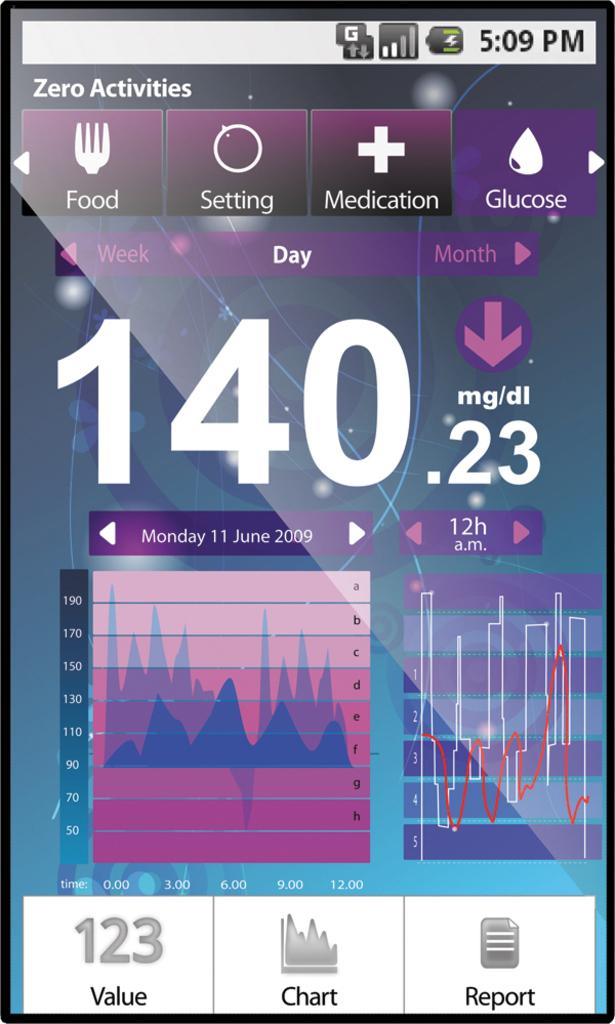<image>
Render a clear and concise summary of the photo. Phone that shows the activities on a chart 